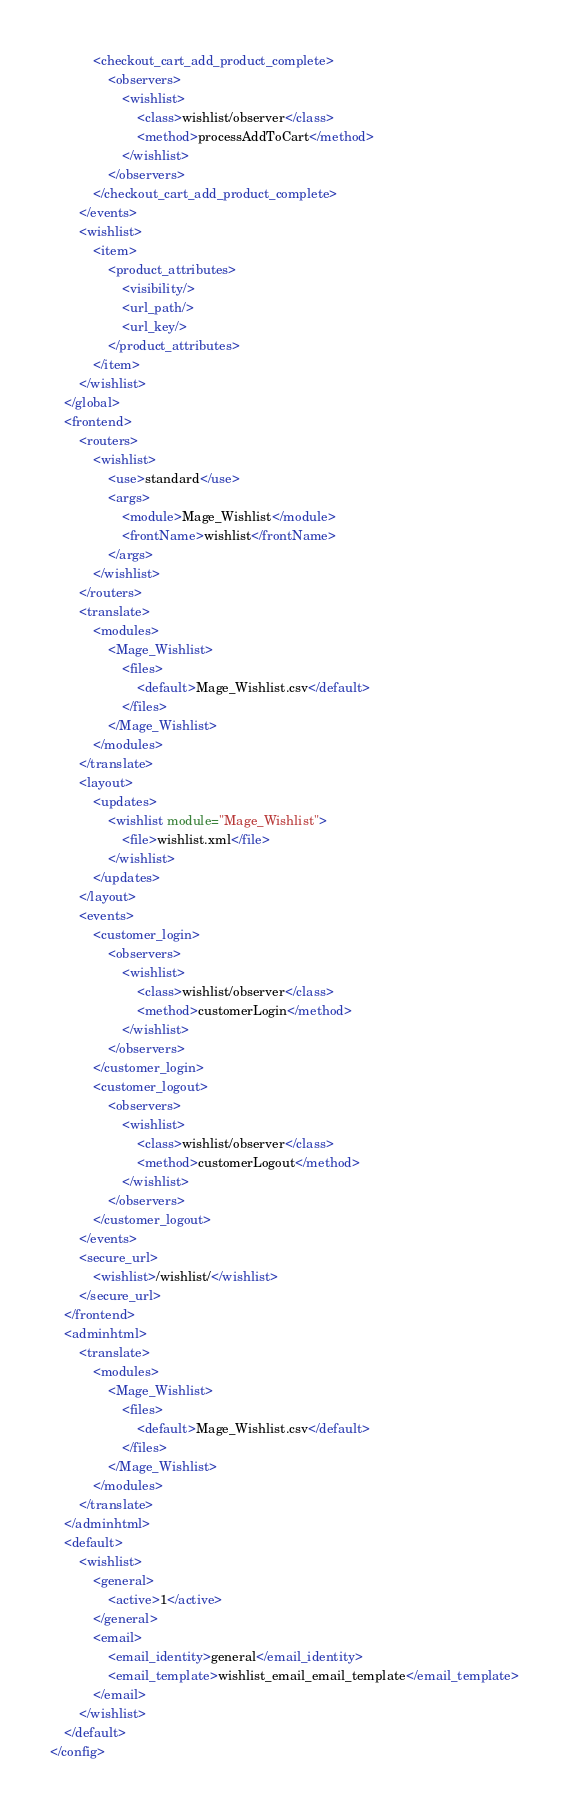Convert code to text. <code><loc_0><loc_0><loc_500><loc_500><_XML_>            <checkout_cart_add_product_complete>
                <observers>
                    <wishlist>
                        <class>wishlist/observer</class>
                        <method>processAddToCart</method>
                    </wishlist>
                </observers>
            </checkout_cart_add_product_complete>
        </events>
        <wishlist>
            <item>
                <product_attributes>
                    <visibility/>
                    <url_path/>
                    <url_key/>
                </product_attributes>
            </item>
        </wishlist>
    </global>
    <frontend>
        <routers>
            <wishlist>
                <use>standard</use>
                <args>
                    <module>Mage_Wishlist</module>
                    <frontName>wishlist</frontName>
                </args>
            </wishlist>
        </routers>
        <translate>
            <modules>
                <Mage_Wishlist>
                    <files>
                        <default>Mage_Wishlist.csv</default>
                    </files>
                </Mage_Wishlist>
            </modules>
        </translate>
        <layout>
            <updates>
                <wishlist module="Mage_Wishlist">
                    <file>wishlist.xml</file>
                </wishlist>
            </updates>
        </layout>
        <events>
            <customer_login>
                <observers>
                    <wishlist>
                        <class>wishlist/observer</class>
                        <method>customerLogin</method>
                    </wishlist>
                </observers>
            </customer_login>
            <customer_logout>
                <observers>
                    <wishlist>
                        <class>wishlist/observer</class>
                        <method>customerLogout</method>
                    </wishlist>
                </observers>
            </customer_logout>
        </events>
        <secure_url>
            <wishlist>/wishlist/</wishlist>
        </secure_url>
    </frontend>
    <adminhtml>
        <translate>
            <modules>
                <Mage_Wishlist>
                    <files>
                        <default>Mage_Wishlist.csv</default>
                    </files>
                </Mage_Wishlist>
            </modules>
        </translate>
    </adminhtml>
    <default>
        <wishlist>
            <general>
                <active>1</active>
            </general>
            <email>
                <email_identity>general</email_identity>
                <email_template>wishlist_email_email_template</email_template>
            </email>
        </wishlist>
    </default>
</config>
</code> 